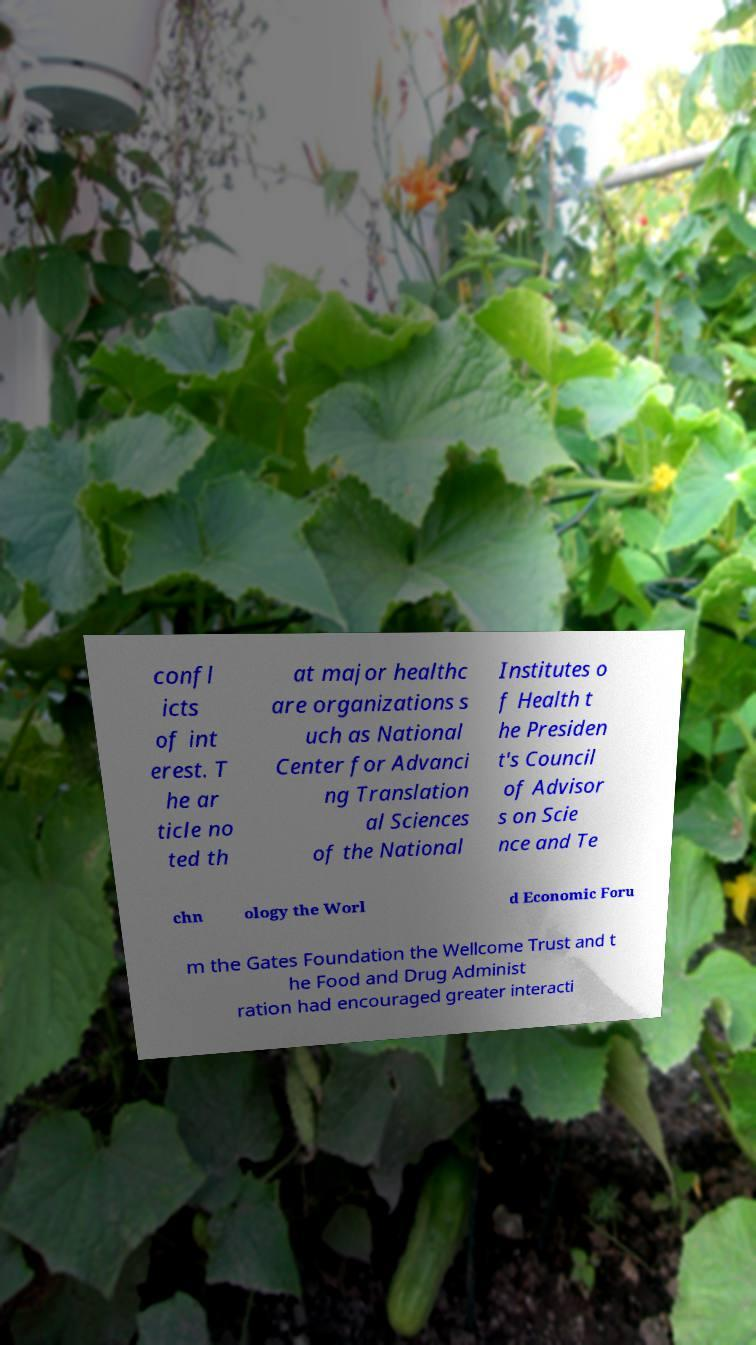Please identify and transcribe the text found in this image. confl icts of int erest. T he ar ticle no ted th at major healthc are organizations s uch as National Center for Advanci ng Translation al Sciences of the National Institutes o f Health t he Presiden t's Council of Advisor s on Scie nce and Te chn ology the Worl d Economic Foru m the Gates Foundation the Wellcome Trust and t he Food and Drug Administ ration had encouraged greater interacti 